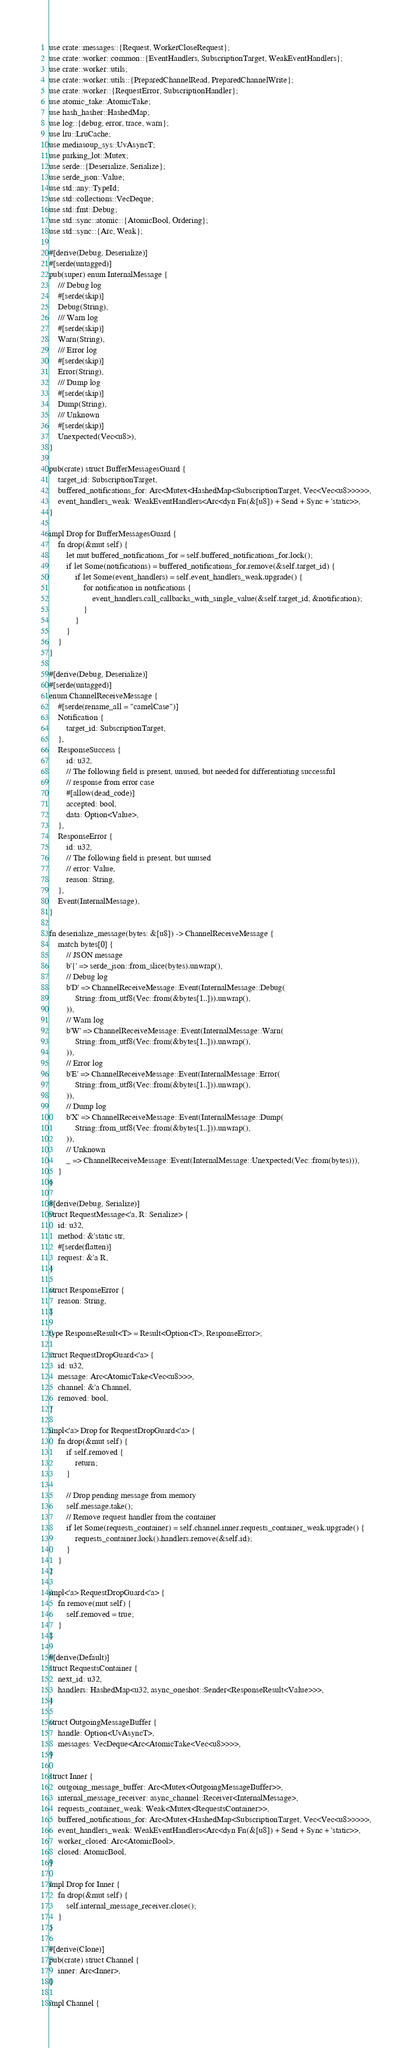<code> <loc_0><loc_0><loc_500><loc_500><_Rust_>use crate::messages::{Request, WorkerCloseRequest};
use crate::worker::common::{EventHandlers, SubscriptionTarget, WeakEventHandlers};
use crate::worker::utils;
use crate::worker::utils::{PreparedChannelRead, PreparedChannelWrite};
use crate::worker::{RequestError, SubscriptionHandler};
use atomic_take::AtomicTake;
use hash_hasher::HashedMap;
use log::{debug, error, trace, warn};
use lru::LruCache;
use mediasoup_sys::UvAsyncT;
use parking_lot::Mutex;
use serde::{Deserialize, Serialize};
use serde_json::Value;
use std::any::TypeId;
use std::collections::VecDeque;
use std::fmt::Debug;
use std::sync::atomic::{AtomicBool, Ordering};
use std::sync::{Arc, Weak};

#[derive(Debug, Deserialize)]
#[serde(untagged)]
pub(super) enum InternalMessage {
    /// Debug log
    #[serde(skip)]
    Debug(String),
    /// Warn log
    #[serde(skip)]
    Warn(String),
    /// Error log
    #[serde(skip)]
    Error(String),
    /// Dump log
    #[serde(skip)]
    Dump(String),
    /// Unknown
    #[serde(skip)]
    Unexpected(Vec<u8>),
}

pub(crate) struct BufferMessagesGuard {
    target_id: SubscriptionTarget,
    buffered_notifications_for: Arc<Mutex<HashedMap<SubscriptionTarget, Vec<Vec<u8>>>>>,
    event_handlers_weak: WeakEventHandlers<Arc<dyn Fn(&[u8]) + Send + Sync + 'static>>,
}

impl Drop for BufferMessagesGuard {
    fn drop(&mut self) {
        let mut buffered_notifications_for = self.buffered_notifications_for.lock();
        if let Some(notifications) = buffered_notifications_for.remove(&self.target_id) {
            if let Some(event_handlers) = self.event_handlers_weak.upgrade() {
                for notification in notifications {
                    event_handlers.call_callbacks_with_single_value(&self.target_id, &notification);
                }
            }
        }
    }
}

#[derive(Debug, Deserialize)]
#[serde(untagged)]
enum ChannelReceiveMessage {
    #[serde(rename_all = "camelCase")]
    Notification {
        target_id: SubscriptionTarget,
    },
    ResponseSuccess {
        id: u32,
        // The following field is present, unused, but needed for differentiating successful
        // response from error case
        #[allow(dead_code)]
        accepted: bool,
        data: Option<Value>,
    },
    ResponseError {
        id: u32,
        // The following field is present, but unused
        // error: Value,
        reason: String,
    },
    Event(InternalMessage),
}

fn deserialize_message(bytes: &[u8]) -> ChannelReceiveMessage {
    match bytes[0] {
        // JSON message
        b'{' => serde_json::from_slice(bytes).unwrap(),
        // Debug log
        b'D' => ChannelReceiveMessage::Event(InternalMessage::Debug(
            String::from_utf8(Vec::from(&bytes[1..])).unwrap(),
        )),
        // Warn log
        b'W' => ChannelReceiveMessage::Event(InternalMessage::Warn(
            String::from_utf8(Vec::from(&bytes[1..])).unwrap(),
        )),
        // Error log
        b'E' => ChannelReceiveMessage::Event(InternalMessage::Error(
            String::from_utf8(Vec::from(&bytes[1..])).unwrap(),
        )),
        // Dump log
        b'X' => ChannelReceiveMessage::Event(InternalMessage::Dump(
            String::from_utf8(Vec::from(&bytes[1..])).unwrap(),
        )),
        // Unknown
        _ => ChannelReceiveMessage::Event(InternalMessage::Unexpected(Vec::from(bytes))),
    }
}

#[derive(Debug, Serialize)]
struct RequestMessage<'a, R: Serialize> {
    id: u32,
    method: &'static str,
    #[serde(flatten)]
    request: &'a R,
}

struct ResponseError {
    reason: String,
}

type ResponseResult<T> = Result<Option<T>, ResponseError>;

struct RequestDropGuard<'a> {
    id: u32,
    message: Arc<AtomicTake<Vec<u8>>>,
    channel: &'a Channel,
    removed: bool,
}

impl<'a> Drop for RequestDropGuard<'a> {
    fn drop(&mut self) {
        if self.removed {
            return;
        }

        // Drop pending message from memory
        self.message.take();
        // Remove request handler from the container
        if let Some(requests_container) = self.channel.inner.requests_container_weak.upgrade() {
            requests_container.lock().handlers.remove(&self.id);
        }
    }
}

impl<'a> RequestDropGuard<'a> {
    fn remove(mut self) {
        self.removed = true;
    }
}

#[derive(Default)]
struct RequestsContainer {
    next_id: u32,
    handlers: HashedMap<u32, async_oneshot::Sender<ResponseResult<Value>>>,
}

struct OutgoingMessageBuffer {
    handle: Option<UvAsyncT>,
    messages: VecDeque<Arc<AtomicTake<Vec<u8>>>>,
}

struct Inner {
    outgoing_message_buffer: Arc<Mutex<OutgoingMessageBuffer>>,
    internal_message_receiver: async_channel::Receiver<InternalMessage>,
    requests_container_weak: Weak<Mutex<RequestsContainer>>,
    buffered_notifications_for: Arc<Mutex<HashedMap<SubscriptionTarget, Vec<Vec<u8>>>>>,
    event_handlers_weak: WeakEventHandlers<Arc<dyn Fn(&[u8]) + Send + Sync + 'static>>,
    worker_closed: Arc<AtomicBool>,
    closed: AtomicBool,
}

impl Drop for Inner {
    fn drop(&mut self) {
        self.internal_message_receiver.close();
    }
}

#[derive(Clone)]
pub(crate) struct Channel {
    inner: Arc<Inner>,
}

impl Channel {</code> 